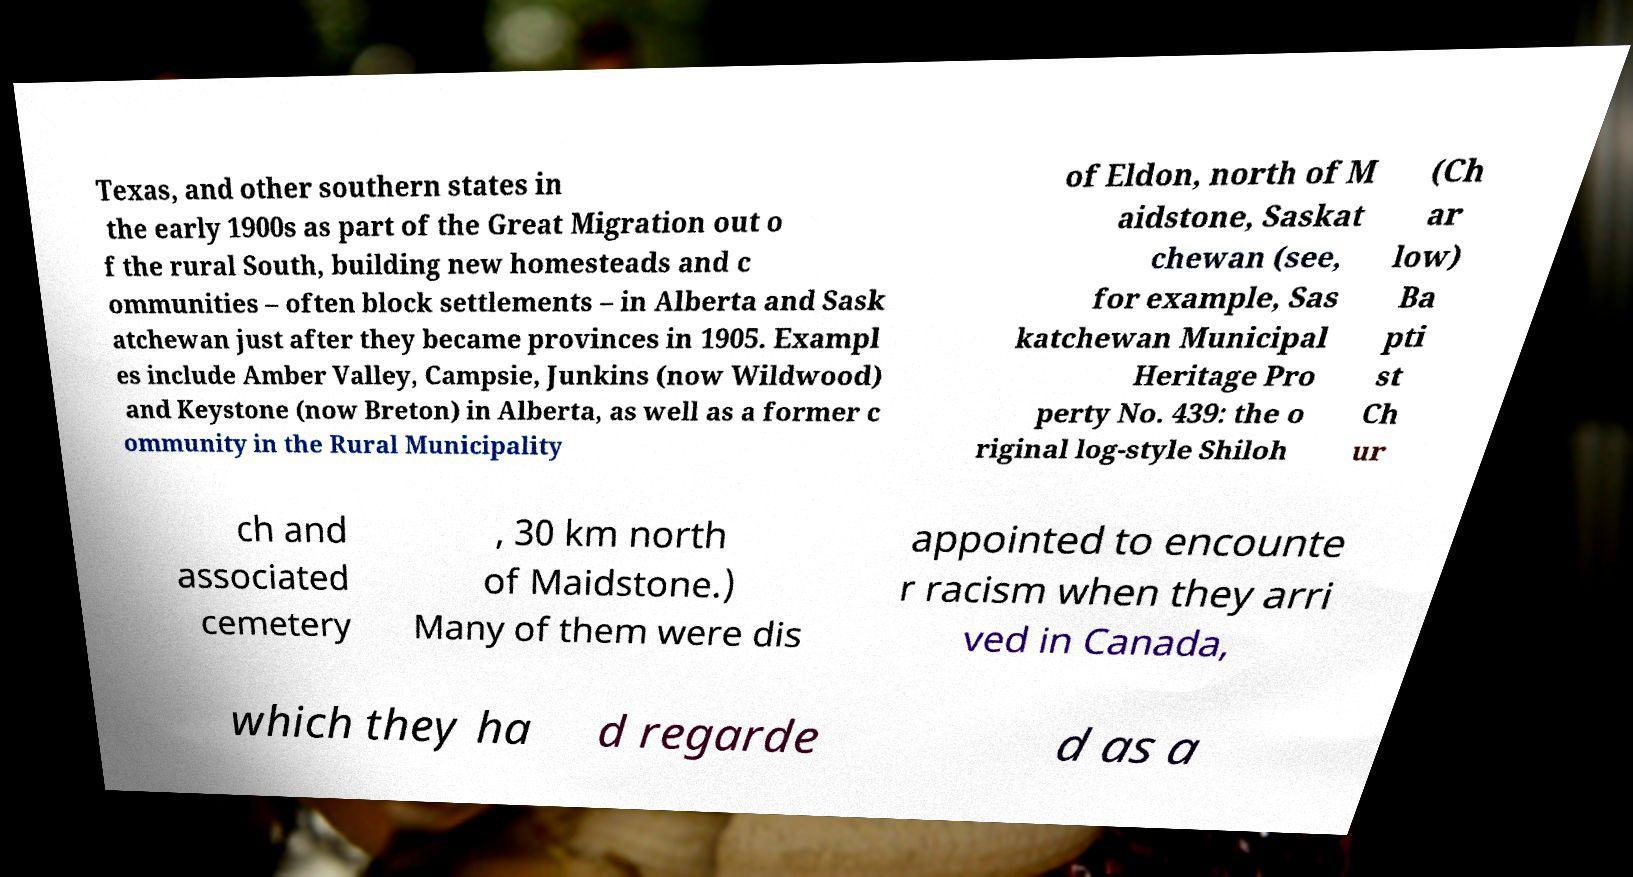Please identify and transcribe the text found in this image. Texas, and other southern states in the early 1900s as part of the Great Migration out o f the rural South, building new homesteads and c ommunities – often block settlements – in Alberta and Sask atchewan just after they became provinces in 1905. Exampl es include Amber Valley, Campsie, Junkins (now Wildwood) and Keystone (now Breton) in Alberta, as well as a former c ommunity in the Rural Municipality of Eldon, north of M aidstone, Saskat chewan (see, for example, Sas katchewan Municipal Heritage Pro perty No. 439: the o riginal log-style Shiloh (Ch ar low) Ba pti st Ch ur ch and associated cemetery , 30 km north of Maidstone.) Many of them were dis appointed to encounte r racism when they arri ved in Canada, which they ha d regarde d as a 